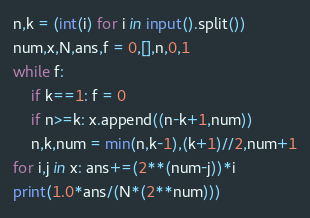<code> <loc_0><loc_0><loc_500><loc_500><_Python_>n,k = (int(i) for i in input().split())
num,x,N,ans,f = 0,[],n,0,1
while f:
    if k==1: f = 0
    if n>=k: x.append((n-k+1,num))
    n,k,num = min(n,k-1),(k+1)//2,num+1
for i,j in x: ans+=(2**(num-j))*i
print(1.0*ans/(N*(2**num)))</code> 